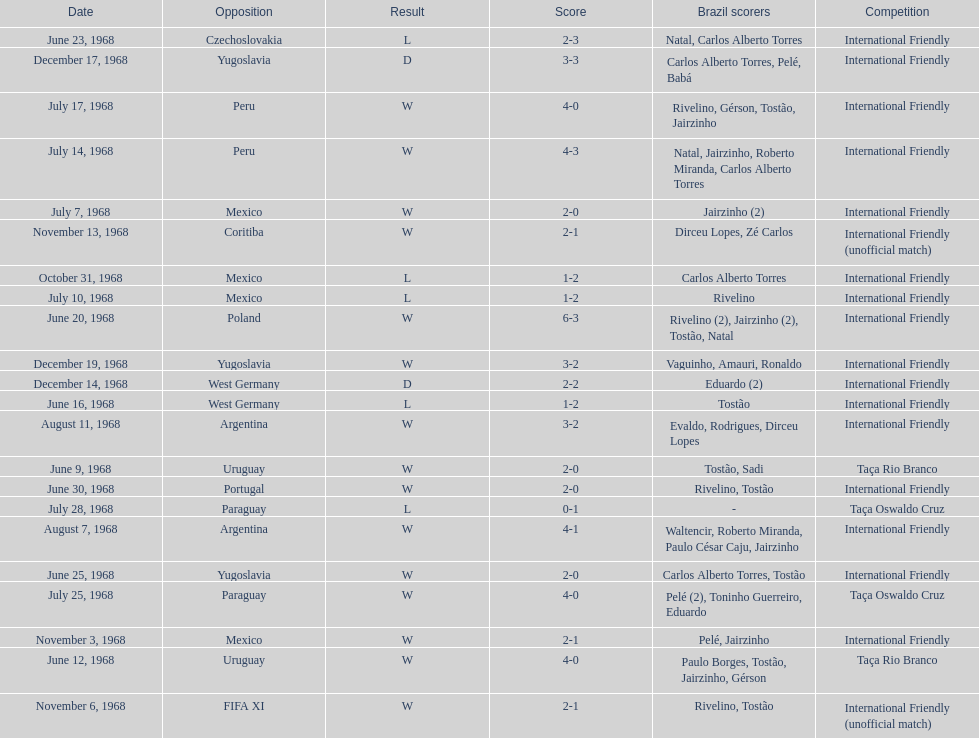How many times did brazil score during the game on november 6th? 2. 